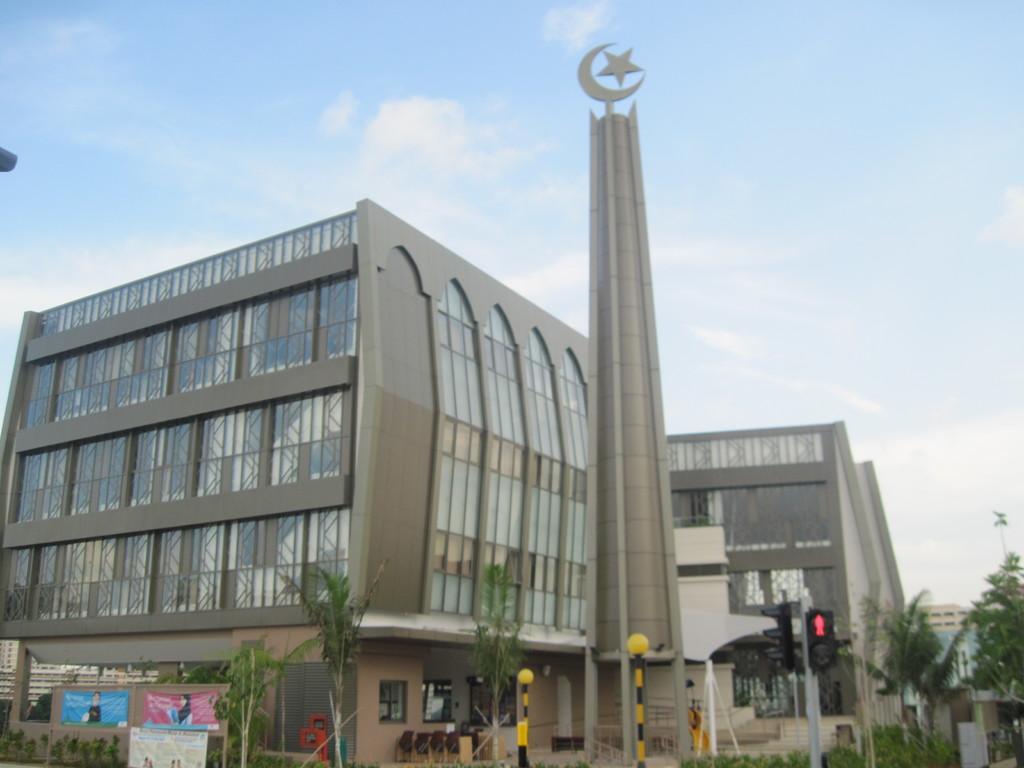Can you describe this image briefly? Here we can see buildings, poles, trees, banners, and traffic signals. In the background there is sky with clouds. 